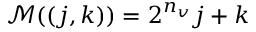<formula> <loc_0><loc_0><loc_500><loc_500>\mathcal { M } ( ( j , k ) ) = 2 ^ { n _ { v } } j + k</formula> 